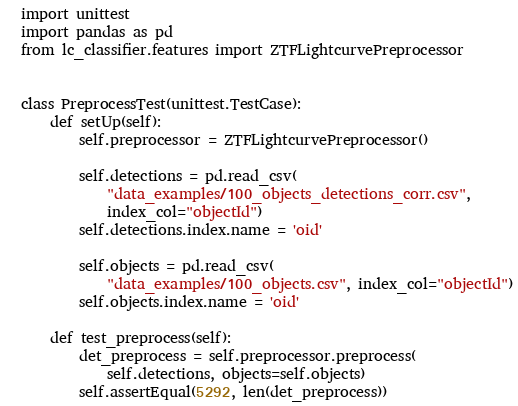Convert code to text. <code><loc_0><loc_0><loc_500><loc_500><_Python_>import unittest
import pandas as pd
from lc_classifier.features import ZTFLightcurvePreprocessor


class PreprocessTest(unittest.TestCase):
    def setUp(self):
        self.preprocessor = ZTFLightcurvePreprocessor()

        self.detections = pd.read_csv(
            "data_examples/100_objects_detections_corr.csv",
            index_col="objectId")
        self.detections.index.name = 'oid'

        self.objects = pd.read_csv(
            "data_examples/100_objects.csv", index_col="objectId")
        self.objects.index.name = 'oid'

    def test_preprocess(self):
        det_preprocess = self.preprocessor.preprocess(
            self.detections, objects=self.objects)
        self.assertEqual(5292, len(det_preprocess))
</code> 